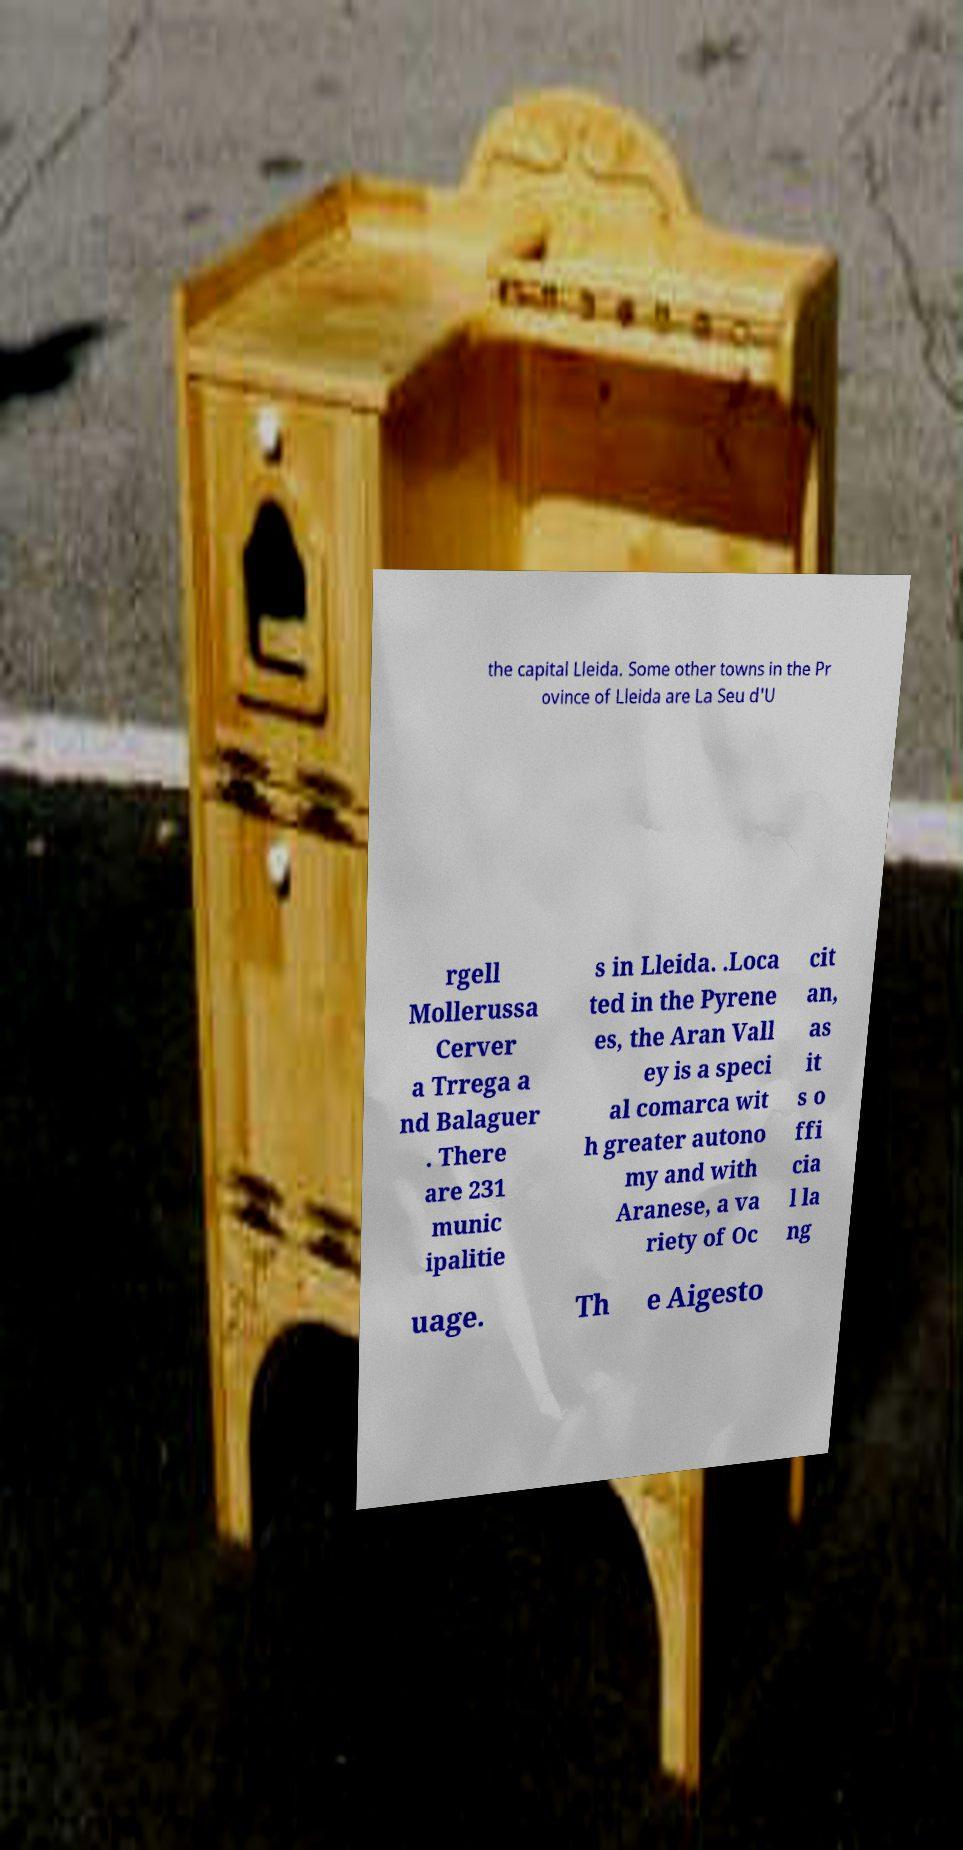Can you read and provide the text displayed in the image?This photo seems to have some interesting text. Can you extract and type it out for me? the capital Lleida. Some other towns in the Pr ovince of Lleida are La Seu d'U rgell Mollerussa Cerver a Trrega a nd Balaguer . There are 231 munic ipalitie s in Lleida. .Loca ted in the Pyrene es, the Aran Vall ey is a speci al comarca wit h greater autono my and with Aranese, a va riety of Oc cit an, as it s o ffi cia l la ng uage. Th e Aigesto 